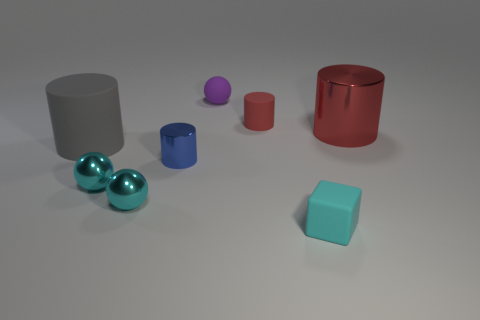Add 1 blue shiny objects. How many objects exist? 9 Subtract all balls. How many objects are left? 5 Add 2 small brown rubber cylinders. How many small brown rubber cylinders exist? 2 Subtract 0 green cylinders. How many objects are left? 8 Subtract all cyan spheres. Subtract all small purple matte spheres. How many objects are left? 5 Add 7 cyan spheres. How many cyan spheres are left? 9 